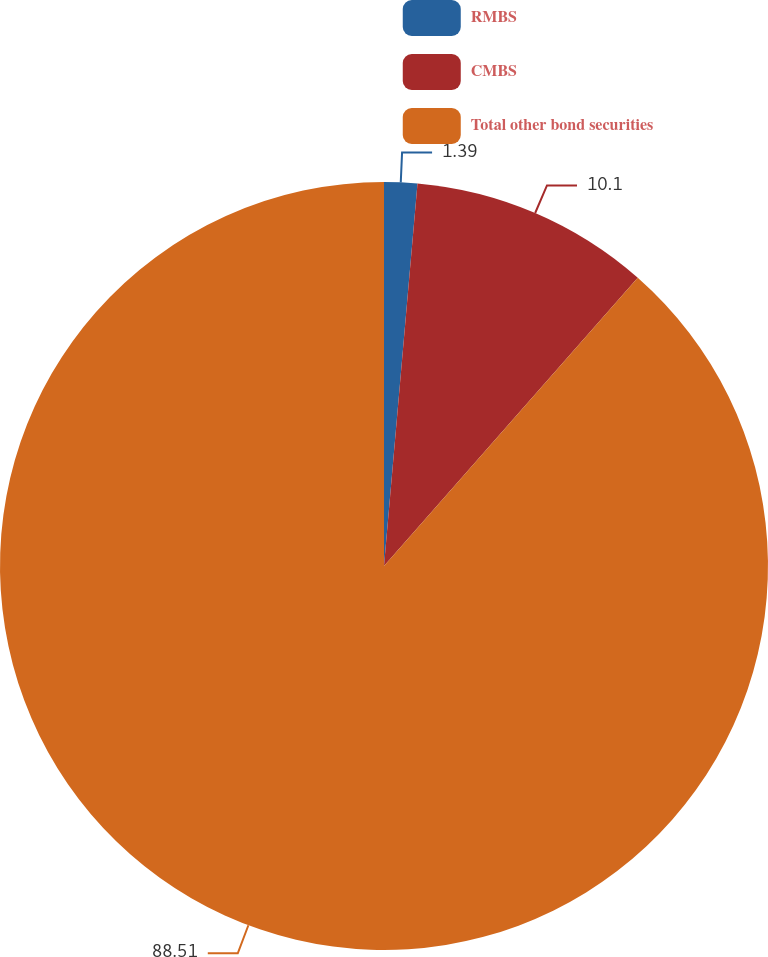Convert chart to OTSL. <chart><loc_0><loc_0><loc_500><loc_500><pie_chart><fcel>RMBS<fcel>CMBS<fcel>Total other bond securities<nl><fcel>1.39%<fcel>10.1%<fcel>88.51%<nl></chart> 